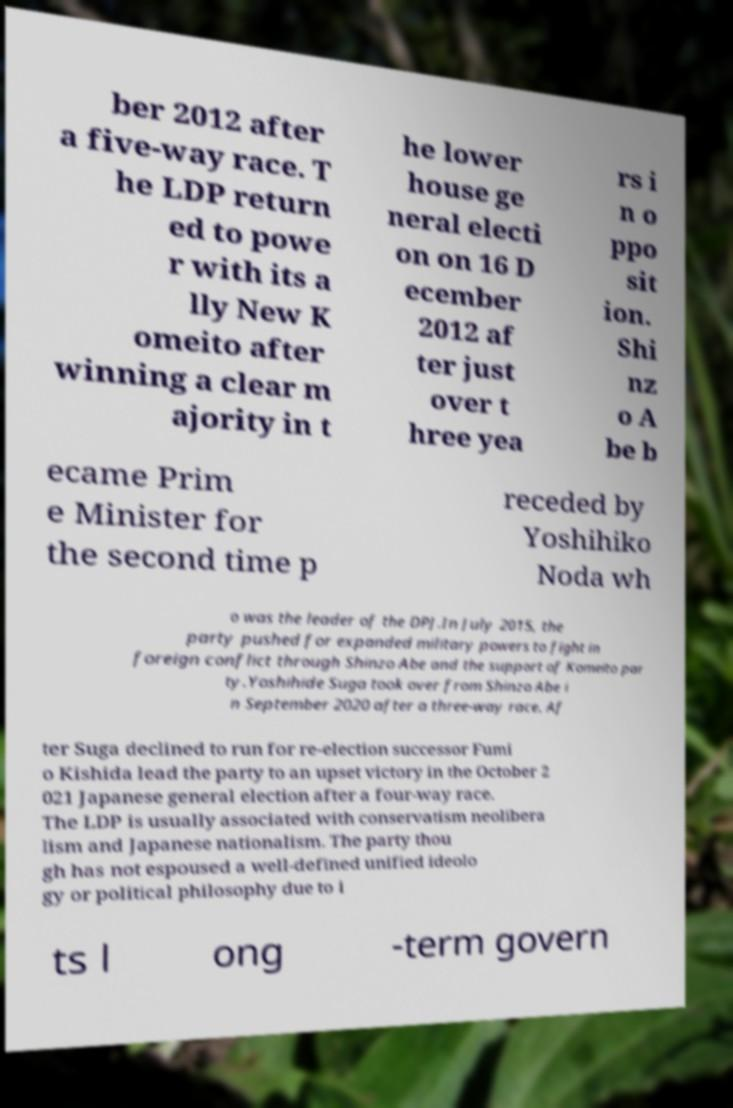Please read and relay the text visible in this image. What does it say? ber 2012 after a five-way race. T he LDP return ed to powe r with its a lly New K omeito after winning a clear m ajority in t he lower house ge neral electi on on 16 D ecember 2012 af ter just over t hree yea rs i n o ppo sit ion. Shi nz o A be b ecame Prim e Minister for the second time p receded by Yoshihiko Noda wh o was the leader of the DPJ.In July 2015, the party pushed for expanded military powers to fight in foreign conflict through Shinzo Abe and the support of Komeito par ty.Yoshihide Suga took over from Shinzo Abe i n September 2020 after a three-way race. Af ter Suga declined to run for re-election successor Fumi o Kishida lead the party to an upset victory in the October 2 021 Japanese general election after a four-way race. The LDP is usually associated with conservatism neolibera lism and Japanese nationalism. The party thou gh has not espoused a well-defined unified ideolo gy or political philosophy due to i ts l ong -term govern 